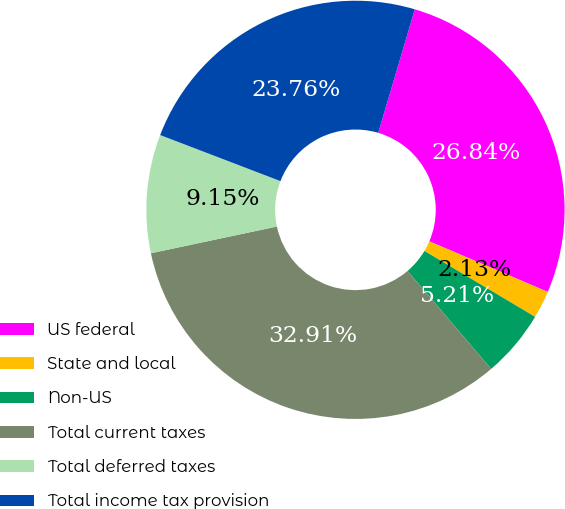Convert chart to OTSL. <chart><loc_0><loc_0><loc_500><loc_500><pie_chart><fcel>US federal<fcel>State and local<fcel>Non-US<fcel>Total current taxes<fcel>Total deferred taxes<fcel>Total income tax provision<nl><fcel>26.84%<fcel>2.13%<fcel>5.21%<fcel>32.91%<fcel>9.15%<fcel>23.76%<nl></chart> 